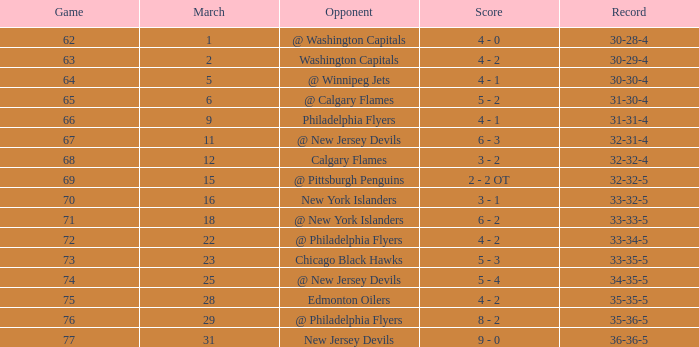How many games ended in a record of 30-28-4, with a March more than 1? 0.0. 